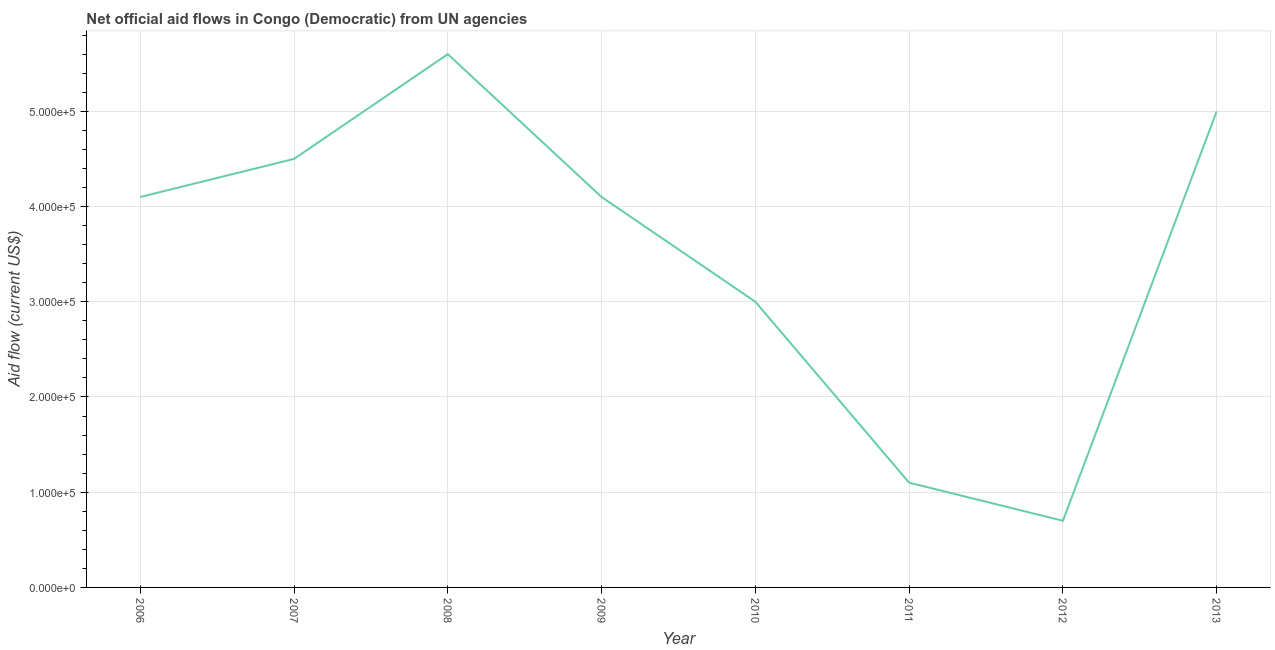What is the net official flows from un agencies in 2012?
Your answer should be compact. 7.00e+04. Across all years, what is the maximum net official flows from un agencies?
Keep it short and to the point. 5.60e+05. Across all years, what is the minimum net official flows from un agencies?
Provide a short and direct response. 7.00e+04. What is the sum of the net official flows from un agencies?
Make the answer very short. 2.81e+06. What is the difference between the net official flows from un agencies in 2008 and 2012?
Your answer should be very brief. 4.90e+05. What is the average net official flows from un agencies per year?
Make the answer very short. 3.51e+05. What is the median net official flows from un agencies?
Provide a short and direct response. 4.10e+05. In how many years, is the net official flows from un agencies greater than 60000 US$?
Make the answer very short. 8. Do a majority of the years between 2009 and 2006 (inclusive) have net official flows from un agencies greater than 280000 US$?
Ensure brevity in your answer.  Yes. What is the ratio of the net official flows from un agencies in 2009 to that in 2013?
Offer a terse response. 0.82. Is the difference between the net official flows from un agencies in 2008 and 2012 greater than the difference between any two years?
Give a very brief answer. Yes. What is the difference between the highest and the lowest net official flows from un agencies?
Offer a terse response. 4.90e+05. Does the net official flows from un agencies monotonically increase over the years?
Give a very brief answer. No. Does the graph contain any zero values?
Provide a short and direct response. No. Does the graph contain grids?
Ensure brevity in your answer.  Yes. What is the title of the graph?
Make the answer very short. Net official aid flows in Congo (Democratic) from UN agencies. What is the label or title of the Y-axis?
Your answer should be very brief. Aid flow (current US$). What is the Aid flow (current US$) in 2008?
Give a very brief answer. 5.60e+05. What is the Aid flow (current US$) in 2013?
Your response must be concise. 5.00e+05. What is the difference between the Aid flow (current US$) in 2006 and 2009?
Ensure brevity in your answer.  0. What is the difference between the Aid flow (current US$) in 2006 and 2011?
Make the answer very short. 3.00e+05. What is the difference between the Aid flow (current US$) in 2007 and 2008?
Your response must be concise. -1.10e+05. What is the difference between the Aid flow (current US$) in 2007 and 2010?
Your answer should be very brief. 1.50e+05. What is the difference between the Aid flow (current US$) in 2007 and 2011?
Your answer should be very brief. 3.40e+05. What is the difference between the Aid flow (current US$) in 2007 and 2013?
Provide a short and direct response. -5.00e+04. What is the difference between the Aid flow (current US$) in 2008 and 2009?
Your answer should be compact. 1.50e+05. What is the difference between the Aid flow (current US$) in 2008 and 2011?
Ensure brevity in your answer.  4.50e+05. What is the difference between the Aid flow (current US$) in 2008 and 2012?
Your answer should be very brief. 4.90e+05. What is the difference between the Aid flow (current US$) in 2009 and 2010?
Give a very brief answer. 1.10e+05. What is the difference between the Aid flow (current US$) in 2009 and 2011?
Your answer should be compact. 3.00e+05. What is the difference between the Aid flow (current US$) in 2009 and 2013?
Make the answer very short. -9.00e+04. What is the difference between the Aid flow (current US$) in 2011 and 2012?
Your answer should be compact. 4.00e+04. What is the difference between the Aid flow (current US$) in 2011 and 2013?
Your answer should be very brief. -3.90e+05. What is the difference between the Aid flow (current US$) in 2012 and 2013?
Your answer should be compact. -4.30e+05. What is the ratio of the Aid flow (current US$) in 2006 to that in 2007?
Provide a succinct answer. 0.91. What is the ratio of the Aid flow (current US$) in 2006 to that in 2008?
Keep it short and to the point. 0.73. What is the ratio of the Aid flow (current US$) in 2006 to that in 2010?
Provide a short and direct response. 1.37. What is the ratio of the Aid flow (current US$) in 2006 to that in 2011?
Your answer should be very brief. 3.73. What is the ratio of the Aid flow (current US$) in 2006 to that in 2012?
Make the answer very short. 5.86. What is the ratio of the Aid flow (current US$) in 2006 to that in 2013?
Keep it short and to the point. 0.82. What is the ratio of the Aid flow (current US$) in 2007 to that in 2008?
Keep it short and to the point. 0.8. What is the ratio of the Aid flow (current US$) in 2007 to that in 2009?
Your answer should be compact. 1.1. What is the ratio of the Aid flow (current US$) in 2007 to that in 2011?
Give a very brief answer. 4.09. What is the ratio of the Aid flow (current US$) in 2007 to that in 2012?
Ensure brevity in your answer.  6.43. What is the ratio of the Aid flow (current US$) in 2007 to that in 2013?
Give a very brief answer. 0.9. What is the ratio of the Aid flow (current US$) in 2008 to that in 2009?
Your answer should be very brief. 1.37. What is the ratio of the Aid flow (current US$) in 2008 to that in 2010?
Give a very brief answer. 1.87. What is the ratio of the Aid flow (current US$) in 2008 to that in 2011?
Keep it short and to the point. 5.09. What is the ratio of the Aid flow (current US$) in 2008 to that in 2013?
Your response must be concise. 1.12. What is the ratio of the Aid flow (current US$) in 2009 to that in 2010?
Your answer should be compact. 1.37. What is the ratio of the Aid flow (current US$) in 2009 to that in 2011?
Provide a succinct answer. 3.73. What is the ratio of the Aid flow (current US$) in 2009 to that in 2012?
Ensure brevity in your answer.  5.86. What is the ratio of the Aid flow (current US$) in 2009 to that in 2013?
Your answer should be very brief. 0.82. What is the ratio of the Aid flow (current US$) in 2010 to that in 2011?
Your answer should be very brief. 2.73. What is the ratio of the Aid flow (current US$) in 2010 to that in 2012?
Your answer should be compact. 4.29. What is the ratio of the Aid flow (current US$) in 2010 to that in 2013?
Ensure brevity in your answer.  0.6. What is the ratio of the Aid flow (current US$) in 2011 to that in 2012?
Ensure brevity in your answer.  1.57. What is the ratio of the Aid flow (current US$) in 2011 to that in 2013?
Keep it short and to the point. 0.22. What is the ratio of the Aid flow (current US$) in 2012 to that in 2013?
Offer a terse response. 0.14. 